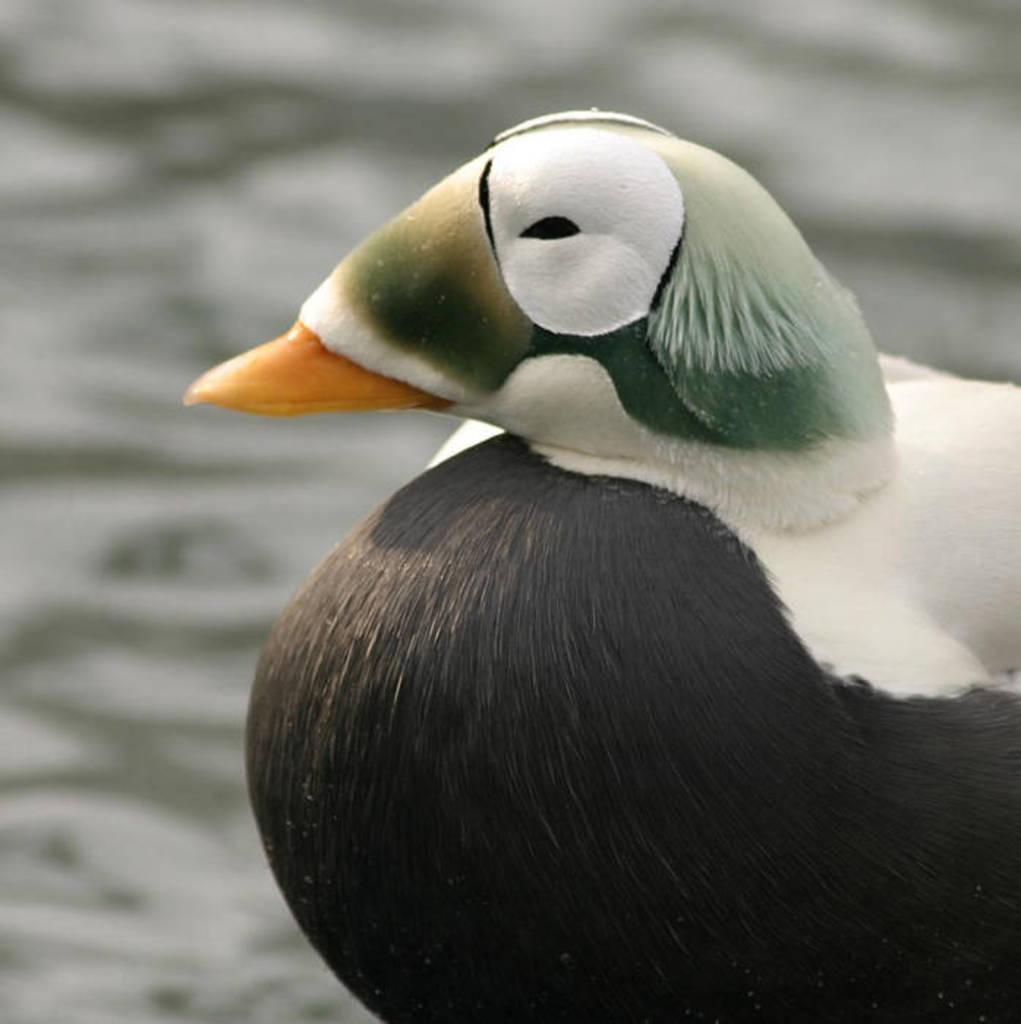In one or two sentences, can you explain what this image depicts? In this image I can see a beautiful bird, it is in black and white color. 